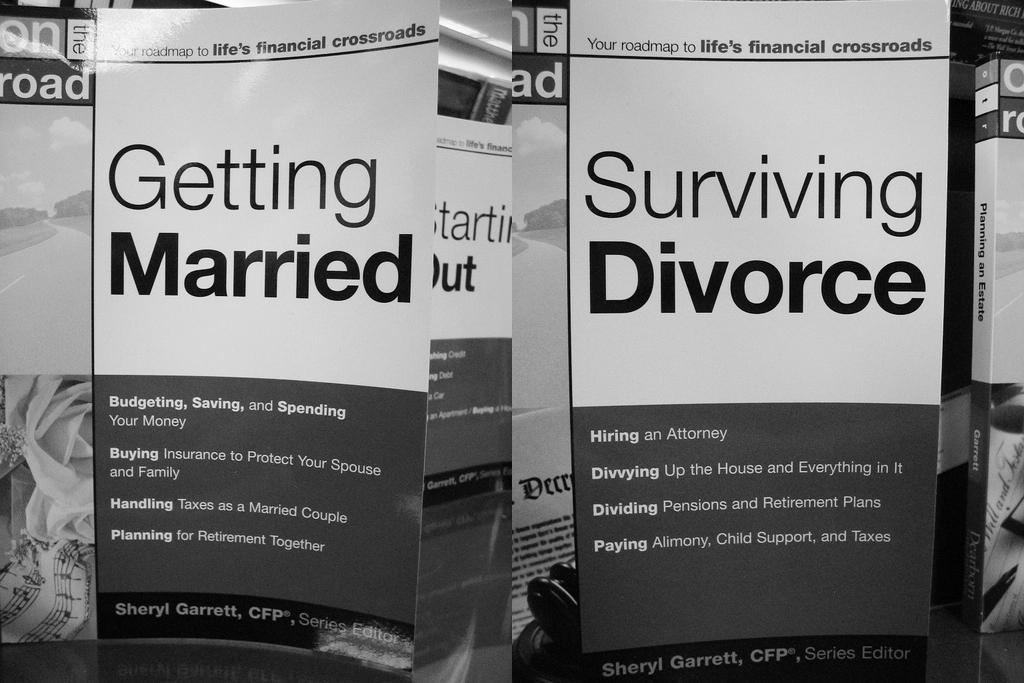<image>
Present a compact description of the photo's key features. A book on surviving divorce by Sheryl Garrett. 